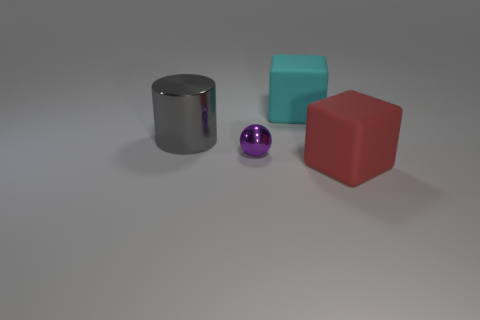Add 2 yellow metal cylinders. How many objects exist? 6 Subtract all spheres. How many objects are left? 3 Add 4 small shiny balls. How many small shiny balls exist? 5 Subtract 0 brown cylinders. How many objects are left? 4 Subtract all red blocks. Subtract all big cyan blocks. How many objects are left? 2 Add 2 small purple metal objects. How many small purple metal objects are left? 3 